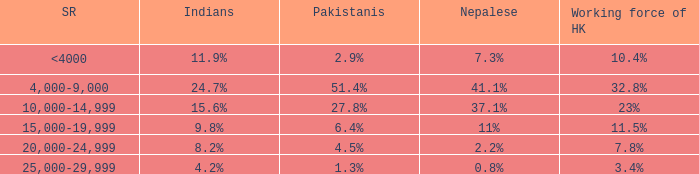If the working force of HK is 32.8%, what are the Pakistanis' %?  51.4%. 